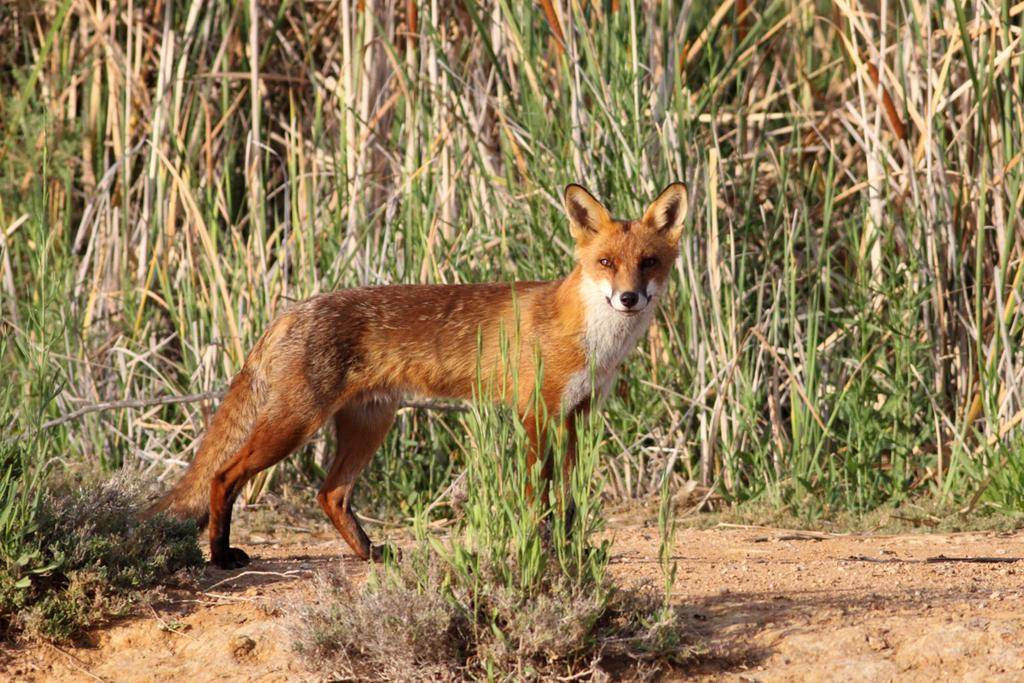What animal can be seen in the image? There is a fox in the image. Where is the fox located? The fox is on the ground. In which direction is the fox facing? The fox is facing towards the right side. What is in front of the fox? There are plants in front of the fox. What is the color of the grass in the background? The grass in the background is green. What type of ring can be seen on the fox's tail in the image? There is no ring present on the fox's tail in the image. Can you tell me where the nearest hospital is in relation to the fox in the image? The image does not provide any information about the location of a hospital, so it cannot be determined from the image. 